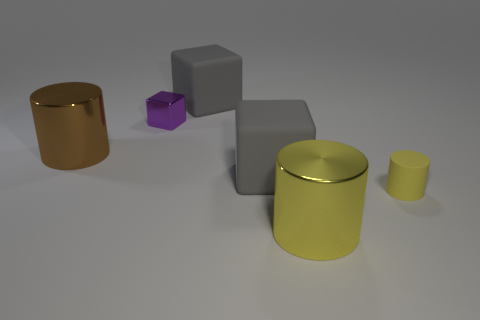There is a shiny cylinder that is behind the shiny cylinder that is in front of the metal cylinder left of the big yellow metal cylinder; how big is it?
Ensure brevity in your answer.  Large. There is a big metallic object that is to the left of the yellow metal cylinder; is there a rubber cylinder that is to the left of it?
Ensure brevity in your answer.  No. What number of tiny yellow objects are to the left of the big metal thing behind the large metal thing in front of the small cylinder?
Your answer should be very brief. 0. What is the color of the large thing that is both in front of the brown metallic cylinder and behind the yellow rubber cylinder?
Give a very brief answer. Gray. How many big things are the same color as the tiny rubber cylinder?
Your answer should be compact. 1. How many cubes are either big purple matte objects or large rubber things?
Offer a terse response. 2. The cylinder that is the same size as the brown shiny object is what color?
Offer a terse response. Yellow. There is a cylinder right of the large cylinder in front of the rubber cylinder; is there a yellow shiny thing that is behind it?
Make the answer very short. No. What is the size of the brown metal thing?
Your answer should be compact. Large. How many objects are either tiny metallic objects or large brown metal cylinders?
Provide a succinct answer. 2. 